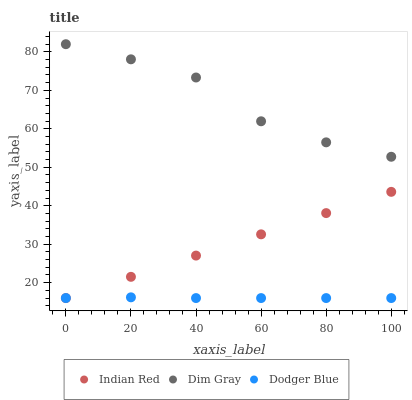Does Dodger Blue have the minimum area under the curve?
Answer yes or no. Yes. Does Dim Gray have the maximum area under the curve?
Answer yes or no. Yes. Does Indian Red have the minimum area under the curve?
Answer yes or no. No. Does Indian Red have the maximum area under the curve?
Answer yes or no. No. Is Indian Red the smoothest?
Answer yes or no. Yes. Is Dim Gray the roughest?
Answer yes or no. Yes. Is Dodger Blue the smoothest?
Answer yes or no. No. Is Dodger Blue the roughest?
Answer yes or no. No. Does Dodger Blue have the lowest value?
Answer yes or no. Yes. Does Dim Gray have the highest value?
Answer yes or no. Yes. Does Indian Red have the highest value?
Answer yes or no. No. Is Dodger Blue less than Dim Gray?
Answer yes or no. Yes. Is Dim Gray greater than Indian Red?
Answer yes or no. Yes. Does Indian Red intersect Dodger Blue?
Answer yes or no. Yes. Is Indian Red less than Dodger Blue?
Answer yes or no. No. Is Indian Red greater than Dodger Blue?
Answer yes or no. No. Does Dodger Blue intersect Dim Gray?
Answer yes or no. No. 